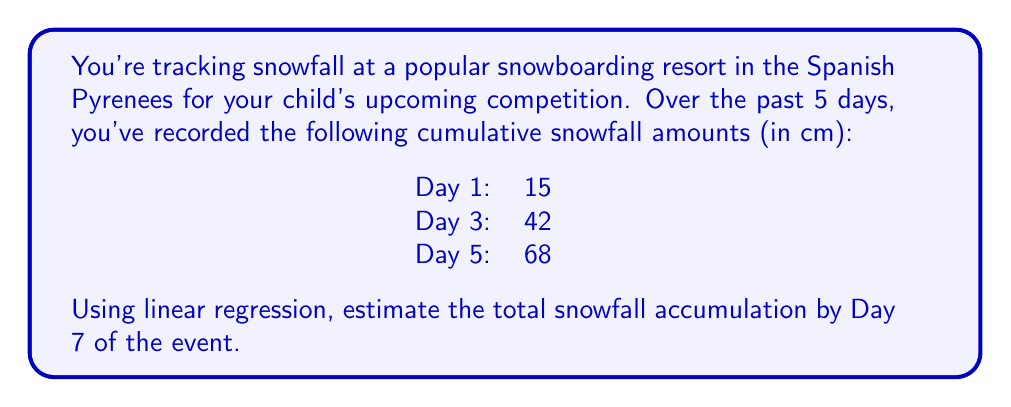Provide a solution to this math problem. To solve this problem, we'll use linear regression to find the line of best fit and then use it to predict the snowfall on Day 7. Let's follow these steps:

1. Identify the data points:
   $(x_1, y_1) = (1, 15)$, $(x_2, y_2) = (3, 42)$, $(x_3, y_3) = (5, 68)$

2. Calculate the means of x and y:
   $\bar{x} = \frac{1 + 3 + 5}{3} = 3$
   $\bar{y} = \frac{15 + 42 + 68}{3} = 41.67$

3. Calculate the slope (m) using the formula:
   $m = \frac{\sum (x_i - \bar{x})(y_i - \bar{y})}{\sum (x_i - \bar{x})^2}$

   $\sum (x_i - \bar{x})(y_i - \bar{y}) = (-2)(-26.67) + (0)(0.33) + (2)(26.33) = 53.34 + 0 + 52.66 = 106$
   $\sum (x_i - \bar{x})^2 = (-2)^2 + (0)^2 + (2)^2 = 4 + 0 + 4 = 8$

   $m = \frac{106}{8} = 13.25$

4. Calculate the y-intercept (b) using the formula:
   $b = \bar{y} - m\bar{x} = 41.67 - 13.25(3) = 1.92$

5. The equation of the line is:
   $y = 13.25x + 1.92$

6. To estimate the snowfall on Day 7, substitute x = 7:
   $y = 13.25(7) + 1.92 = 94.67$

Therefore, the estimated total snowfall accumulation by Day 7 is approximately 94.67 cm.
Answer: 94.67 cm 